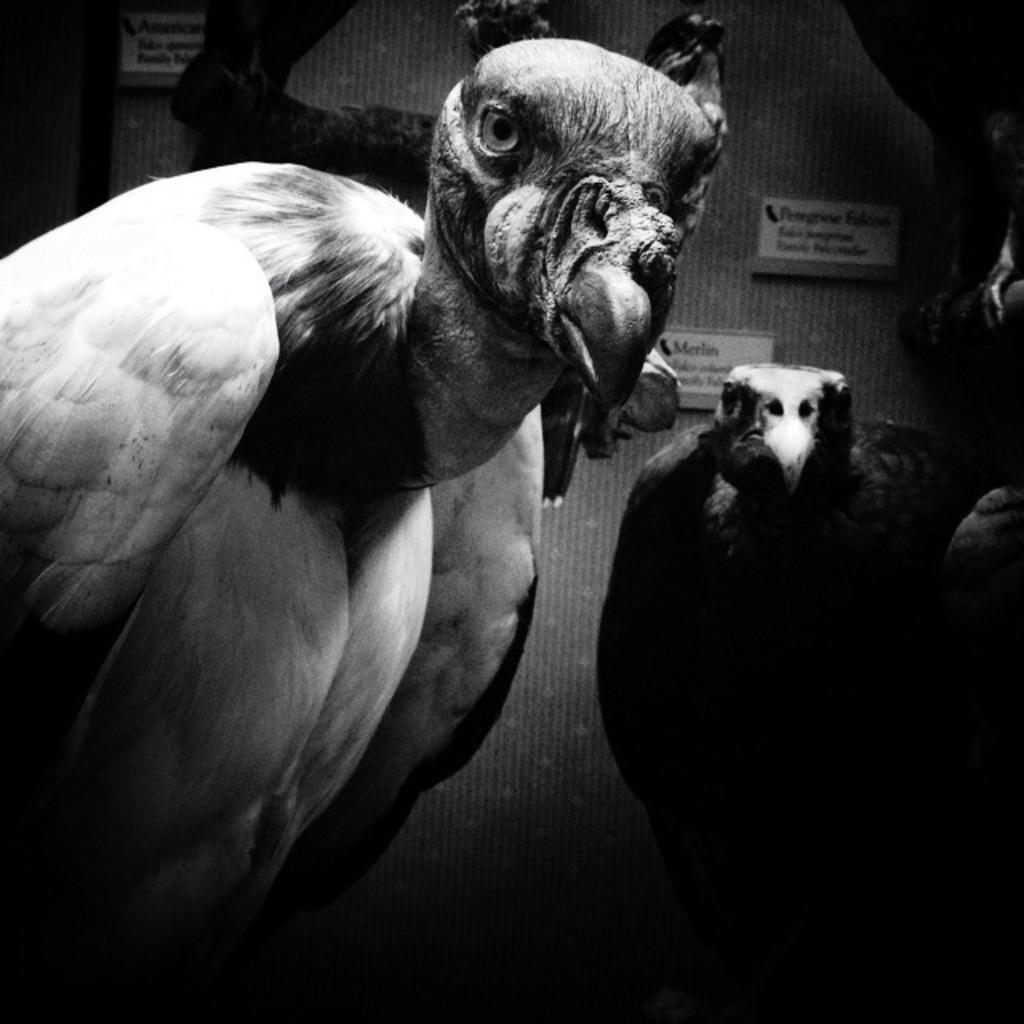Can you describe this image briefly? It is a black and white image, there are two eagles in the picture and in background there are some posters attached to the wall. 